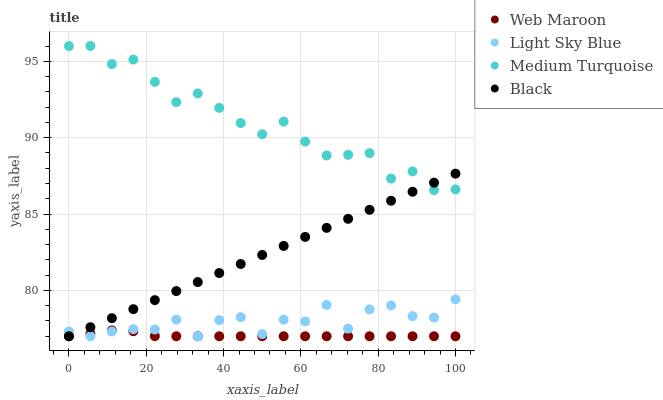Does Web Maroon have the minimum area under the curve?
Answer yes or no. Yes. Does Medium Turquoise have the maximum area under the curve?
Answer yes or no. Yes. Does Light Sky Blue have the minimum area under the curve?
Answer yes or no. No. Does Light Sky Blue have the maximum area under the curve?
Answer yes or no. No. Is Black the smoothest?
Answer yes or no. Yes. Is Light Sky Blue the roughest?
Answer yes or no. Yes. Is Web Maroon the smoothest?
Answer yes or no. No. Is Web Maroon the roughest?
Answer yes or no. No. Does Black have the lowest value?
Answer yes or no. Yes. Does Medium Turquoise have the lowest value?
Answer yes or no. No. Does Medium Turquoise have the highest value?
Answer yes or no. Yes. Does Light Sky Blue have the highest value?
Answer yes or no. No. Is Web Maroon less than Medium Turquoise?
Answer yes or no. Yes. Is Medium Turquoise greater than Light Sky Blue?
Answer yes or no. Yes. Does Black intersect Web Maroon?
Answer yes or no. Yes. Is Black less than Web Maroon?
Answer yes or no. No. Is Black greater than Web Maroon?
Answer yes or no. No. Does Web Maroon intersect Medium Turquoise?
Answer yes or no. No. 